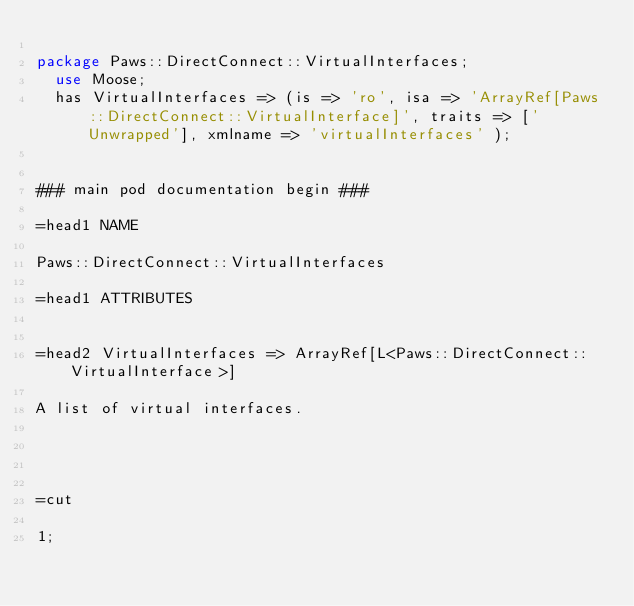<code> <loc_0><loc_0><loc_500><loc_500><_Perl_>
package Paws::DirectConnect::VirtualInterfaces;
  use Moose;
  has VirtualInterfaces => (is => 'ro', isa => 'ArrayRef[Paws::DirectConnect::VirtualInterface]', traits => ['Unwrapped'], xmlname => 'virtualInterfaces' );


### main pod documentation begin ###

=head1 NAME

Paws::DirectConnect::VirtualInterfaces

=head1 ATTRIBUTES


=head2 VirtualInterfaces => ArrayRef[L<Paws::DirectConnect::VirtualInterface>]

A list of virtual interfaces.




=cut

1;</code> 